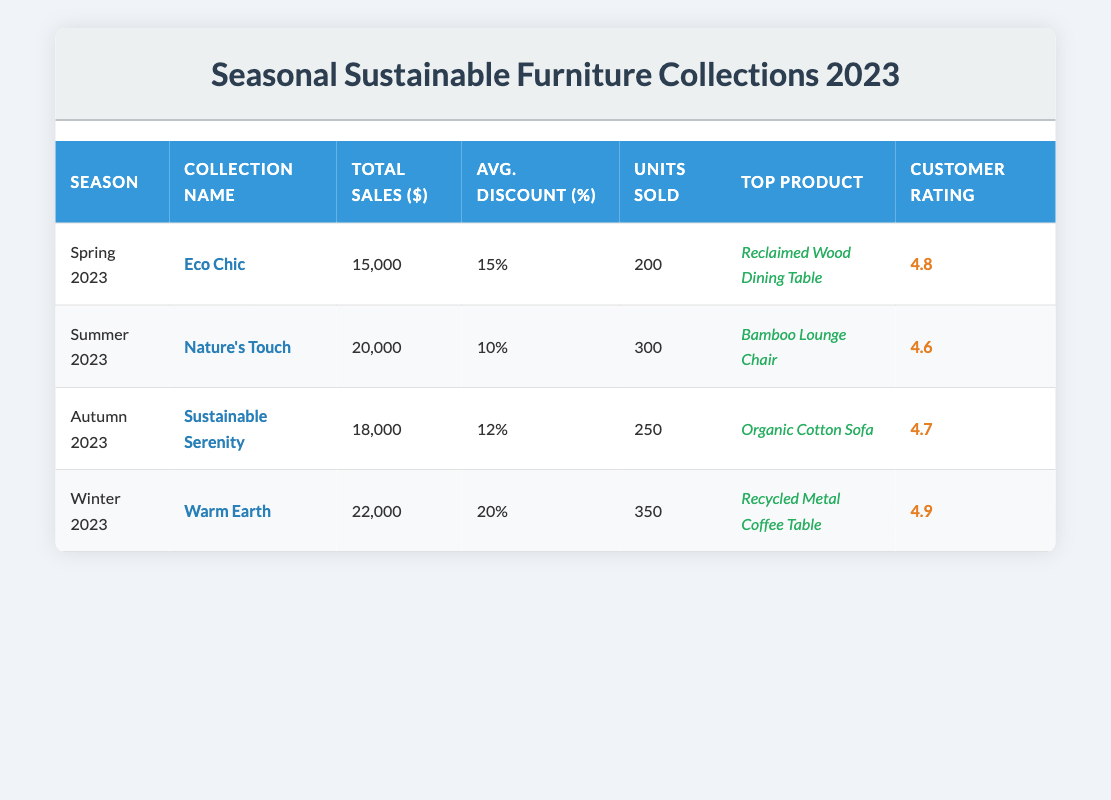What was the total sales for the Winter 2023 collection? Looking at the table, the row for Winter 2023 shows that total sales are listed as 22,000.
Answer: 22,000 Which collection had the highest average discount? By comparing the average discounts from each row, Winter 2023 has the highest average discount at 20%. Other discounts are 15%, 10%, and 12% respectively, making Winter the highest.
Answer: Winter 2023 How many units were sold in Autumn 2023? From the Autumn 2023 row in the table, the units sold are listed as 250.
Answer: 250 What is the average customer feedback rating across all seasons? To find the average rating, first, add all the ratings (4.8 + 4.6 + 4.7 + 4.9 = 19.0) and then divide by the number of seasons (4). Thus, 19.0 divided by 4 equals 4.75.
Answer: 4.75 Did Nature's Touch have more sales than Eco Chic? Comparing total sales, Nature’s Touch sales are 20,000 while Eco Chic’s is 15,000. Therefore, Nature's Touch sales are greater than Eco Chic's.
Answer: Yes Which season had the lowest total sales? A quick glance at the total sales across seasons shows that Eco Chic in Spring 2023 had the lowest total sales at 15,000 compared to others that are 20,000, 18,000, and 22,000.
Answer: Spring 2023 What product received the highest customer feedback rating? The highest rating recorded is 4.9 for the top product in the Winter 2023 collection, the “Recycled Metal Coffee Table.” Comparing all, that rating is the highest.
Answer: Recycled Metal Coffee Table What is the difference in units sold between Summer and Autumn 2023? For Summer 2023, units sold are 300 and for Autumn 2023, units sold are 250. The difference is 300 - 250 = 50.
Answer: 50 Which collection had the highest total sales and what was the amount? Reviewing the total sales, Winter 2023 with the "Warm Earth" collection had the highest total sales at 22,000 as compared to other collections.
Answer: Warm Earth, 22,000 